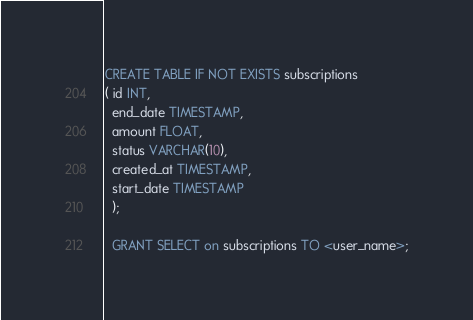Convert code to text. <code><loc_0><loc_0><loc_500><loc_500><_SQL_>CREATE TABLE IF NOT EXISTS subscriptions
( id INT,
  end_date TIMESTAMP,
  amount FLOAT,
  status VARCHAR(10),
  created_at TIMESTAMP,
  start_date TIMESTAMP
  );
  
  GRANT SELECT on subscriptions TO <user_name>;
</code> 